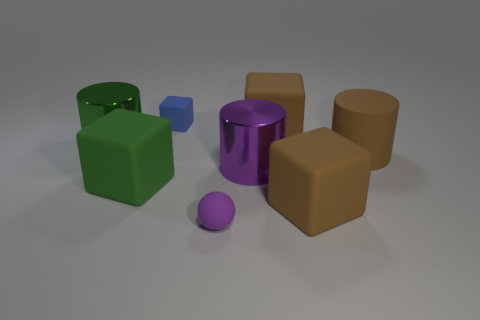Do the green rubber block and the purple matte thing in front of the brown matte cylinder have the same size?
Offer a terse response. No. How many other objects are there of the same shape as the purple metal thing?
Offer a very short reply. 2. What shape is the green object that is the same material as the purple cylinder?
Ensure brevity in your answer.  Cylinder. Are any blue shiny spheres visible?
Your answer should be very brief. No. Is the number of brown blocks that are on the left side of the green matte object less than the number of purple matte objects that are on the left side of the green metallic cylinder?
Your answer should be very brief. No. There is a metallic thing left of the blue rubber object; what shape is it?
Give a very brief answer. Cylinder. Do the tiny purple sphere and the small blue object have the same material?
Provide a succinct answer. Yes. What material is the blue object that is the same shape as the big green rubber object?
Provide a succinct answer. Rubber. Are there fewer big purple metallic cylinders in front of the matte ball than small red things?
Your answer should be very brief. No. How many small objects are behind the matte cylinder?
Provide a short and direct response. 1. 